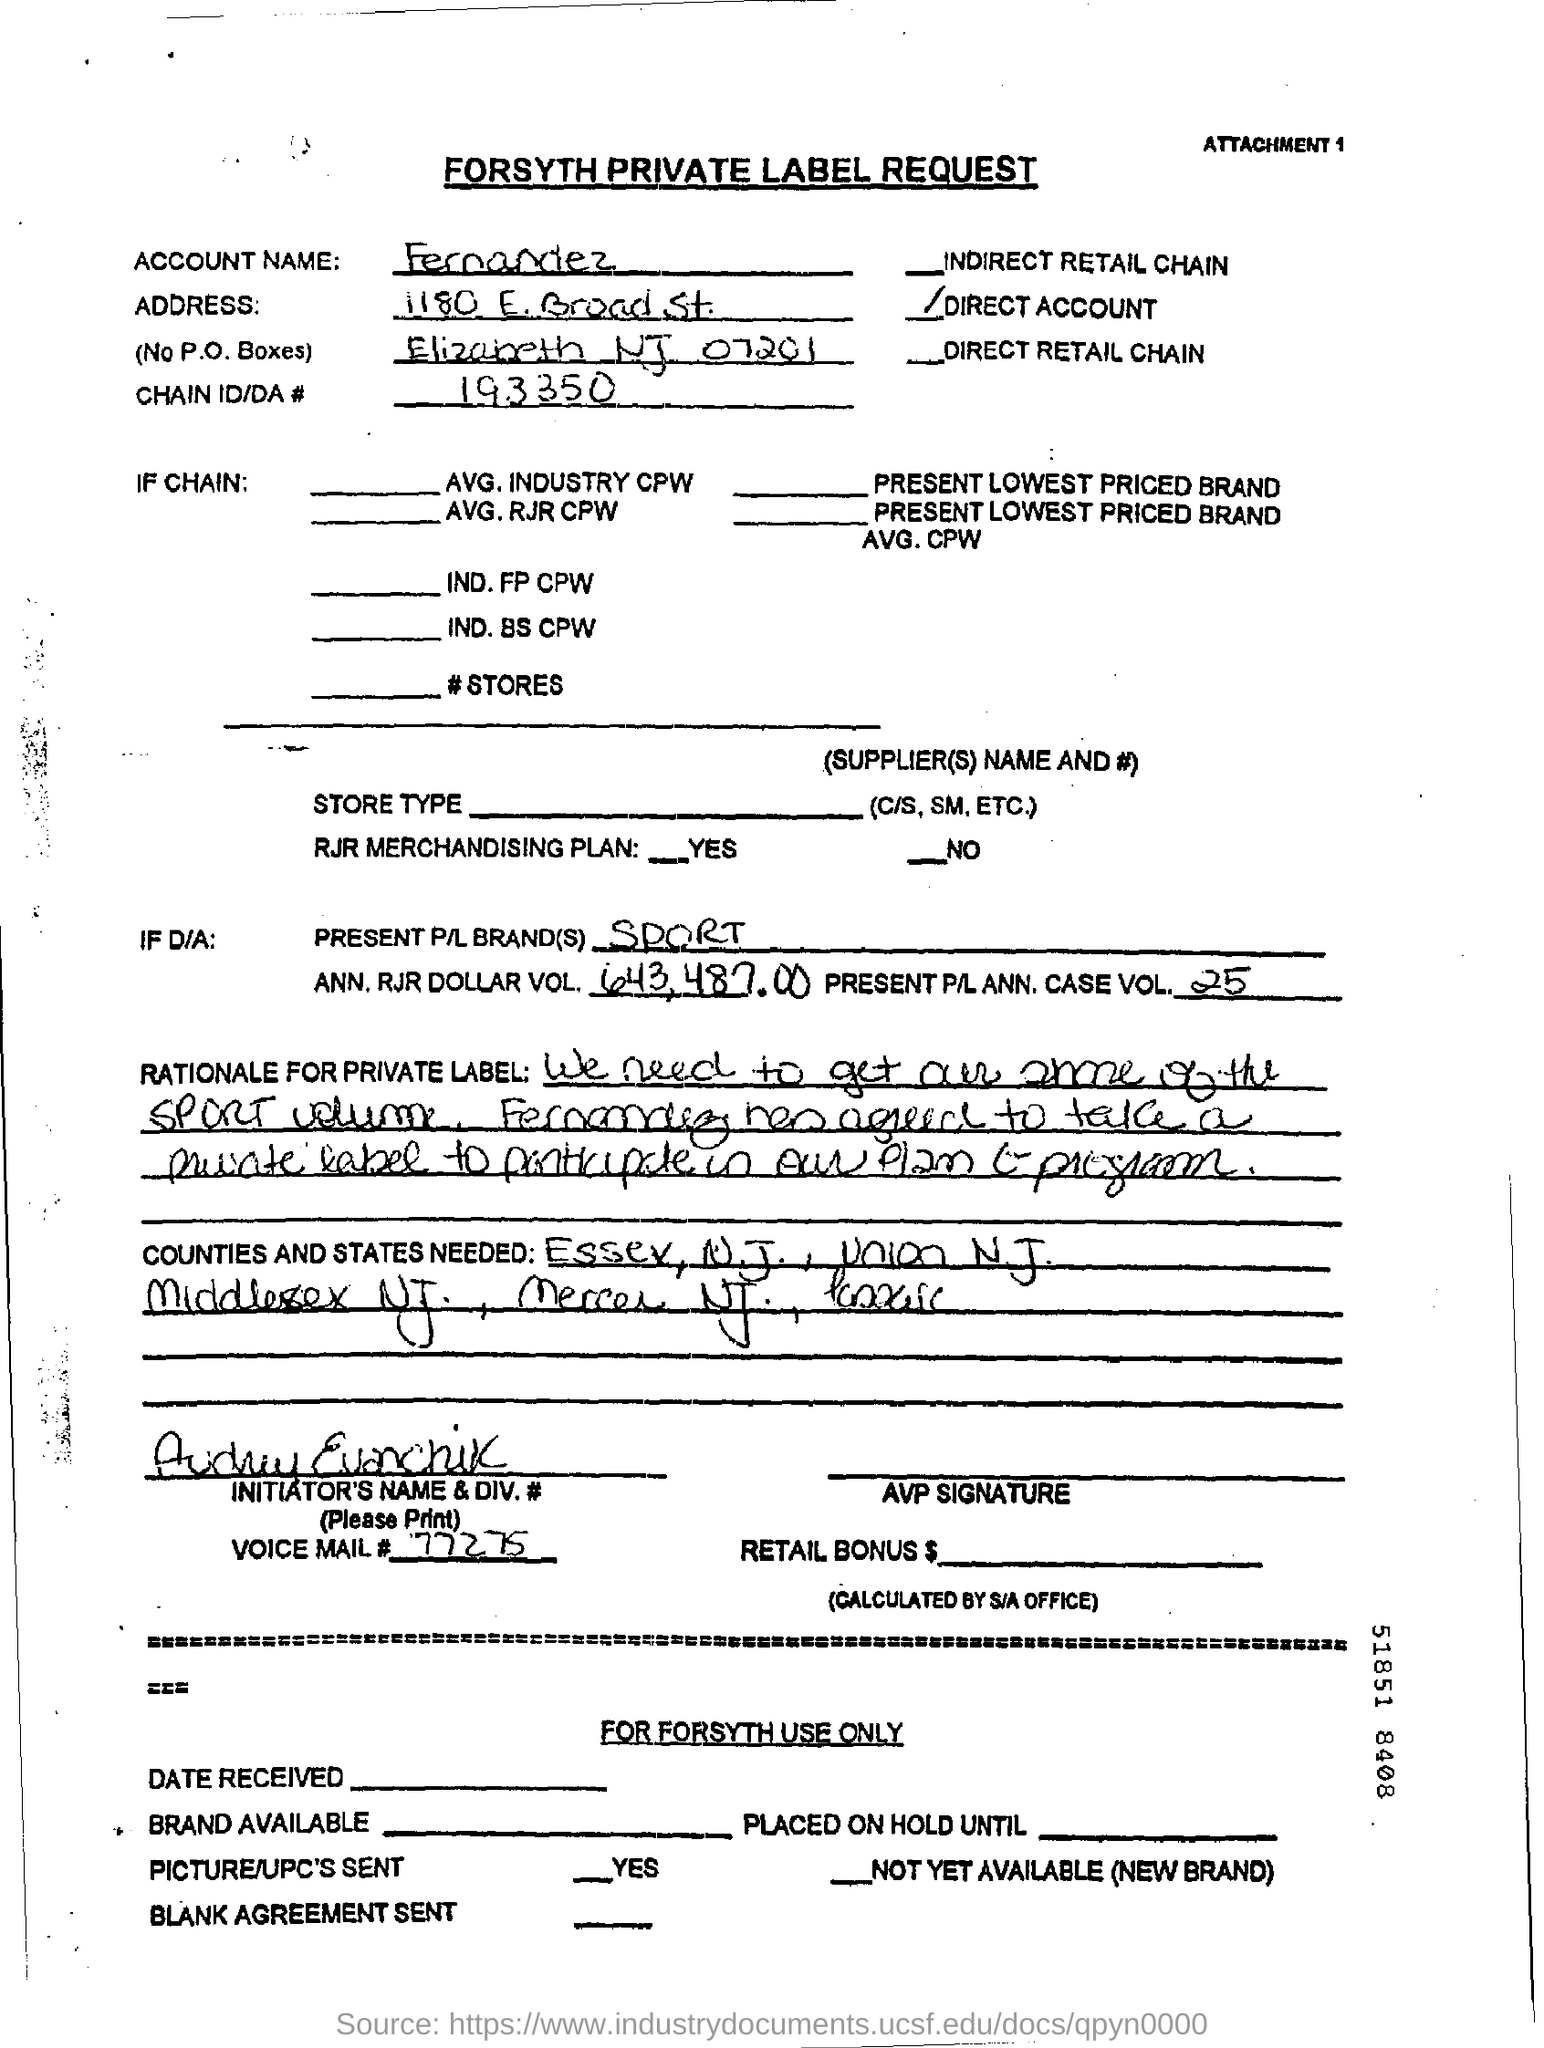Give some essential details in this illustration. The present P/L brand(s) for sport are... The dollar volume for ANN is RJR DOLLAR VOL. 643,487.00. The Chain ID/DA # is 193350. The account name is fernandez. The present P/L ANN case volume is 25. 